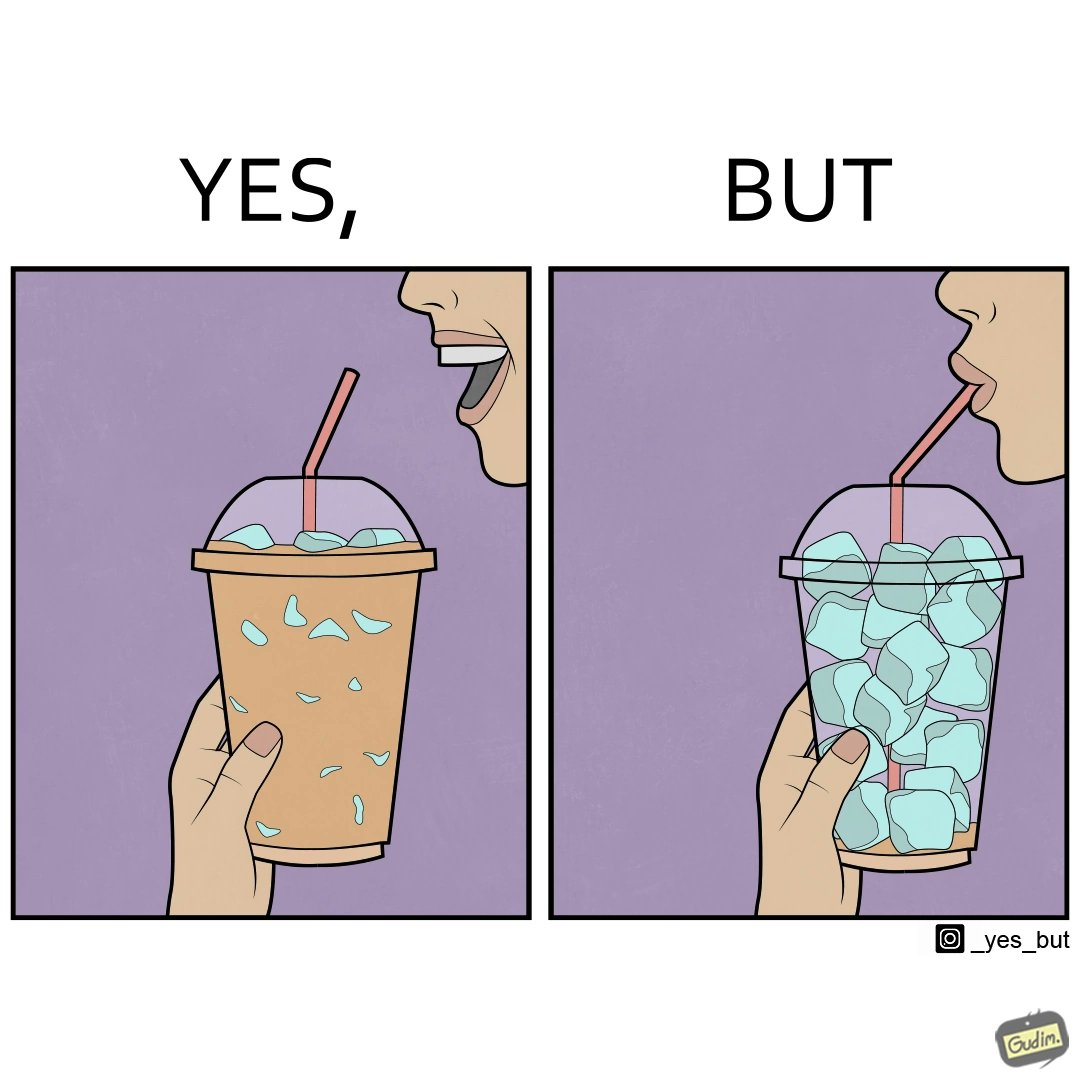Is this a satirical image? Yes, this image is satirical. 